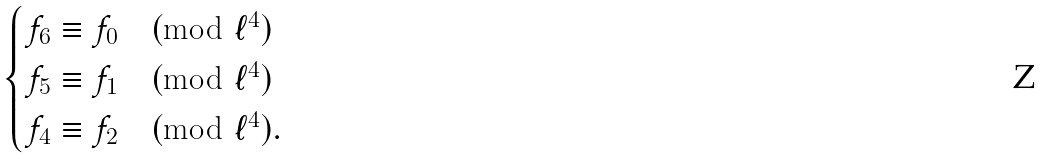<formula> <loc_0><loc_0><loc_500><loc_500>\begin{cases} f _ { 6 } \equiv f _ { 0 } \pmod { \ell ^ { 4 } } \\ f _ { 5 } \equiv f _ { 1 } \pmod { \ell ^ { 4 } } \\ f _ { 4 } \equiv f _ { 2 } \pmod { \ell ^ { 4 } } . \end{cases}</formula> 